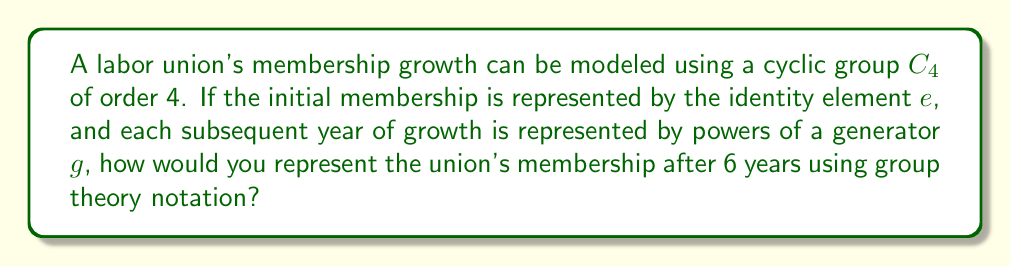Can you solve this math problem? Let's approach this step-by-step:

1) The cyclic group $C_4$ has elements $\{e, g, g^2, g^3\}$, where $e$ is the identity element and $g$ is the generator.

2) Each year of growth is represented by multiplying by $g$. So after one year, the membership is represented by $g$, after two years by $g^2$, and so on.

3) After 6 years, we would have $g^6$. However, we need to consider that we're working in $C_4$, where $g^4 = e$.

4) To find $g^6$ in $C_4$, we can use the division algorithm:
   
   $6 = 1 \cdot 4 + 2$

5) This means that $g^6 = g^4 \cdot g^2 = e \cdot g^2 = g^2$

Therefore, the union's membership after 6 years would be represented by $g^2$ in $C_4$.
Answer: $g^2$ 